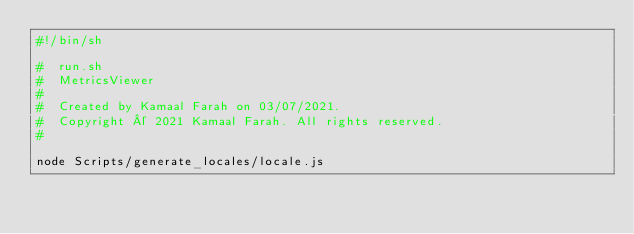<code> <loc_0><loc_0><loc_500><loc_500><_Bash_>#!/bin/sh

#  run.sh
#  MetricsViewer
#
#  Created by Kamaal Farah on 03/07/2021.
#  Copyright © 2021 Kamaal Farah. All rights reserved.
#

node Scripts/generate_locales/locale.js
</code> 